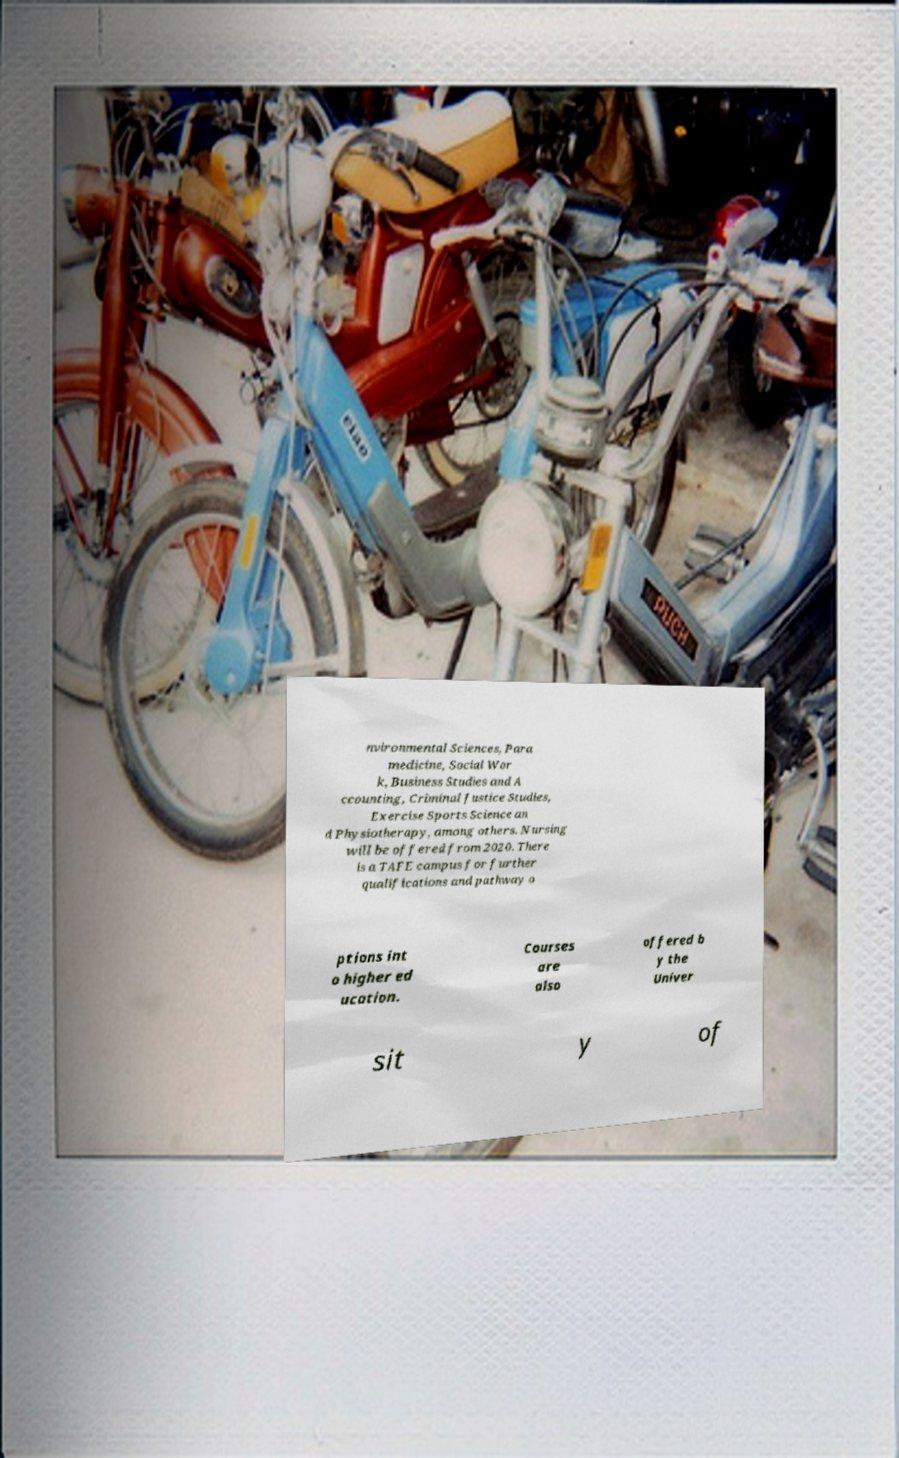Please read and relay the text visible in this image. What does it say? nvironmental Sciences, Para medicine, Social Wor k, Business Studies and A ccounting, Criminal Justice Studies, Exercise Sports Science an d Physiotherapy, among others. Nursing will be offered from 2020. There is a TAFE campus for further qualifications and pathway o ptions int o higher ed ucation. Courses are also offered b y the Univer sit y of 